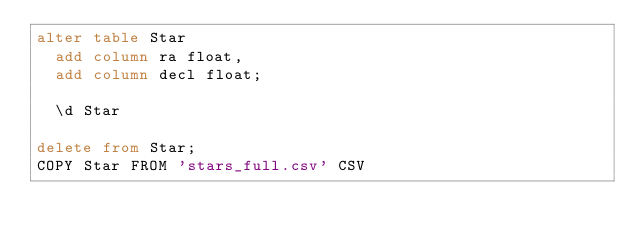<code> <loc_0><loc_0><loc_500><loc_500><_SQL_>alter table Star
  add column ra float,
  add column decl float;
  
  \d Star

delete from Star;
COPY Star FROM 'stars_full.csv' CSV

</code> 